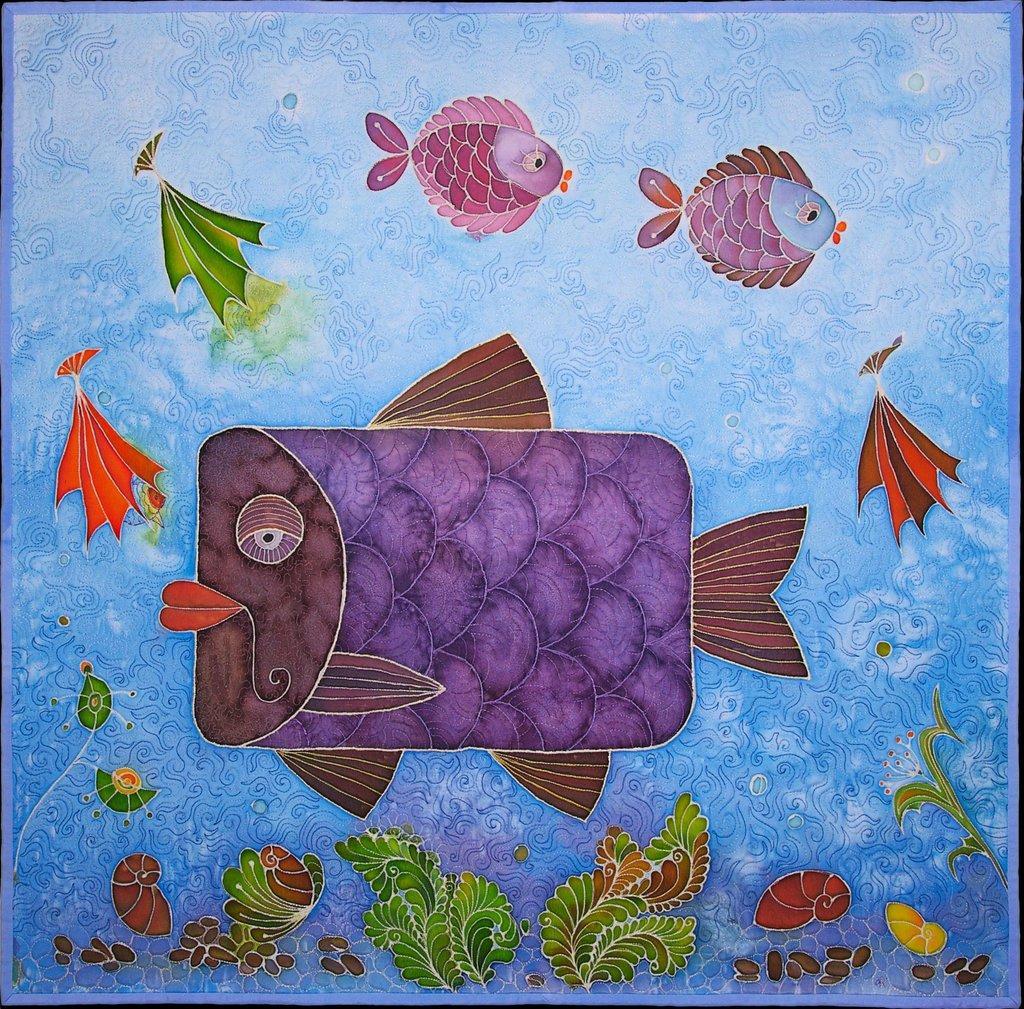In one or two sentences, can you explain what this image depicts? This is a painted poster, where we can see paintings of fishes, tortoise, plants, snail, and the water. 